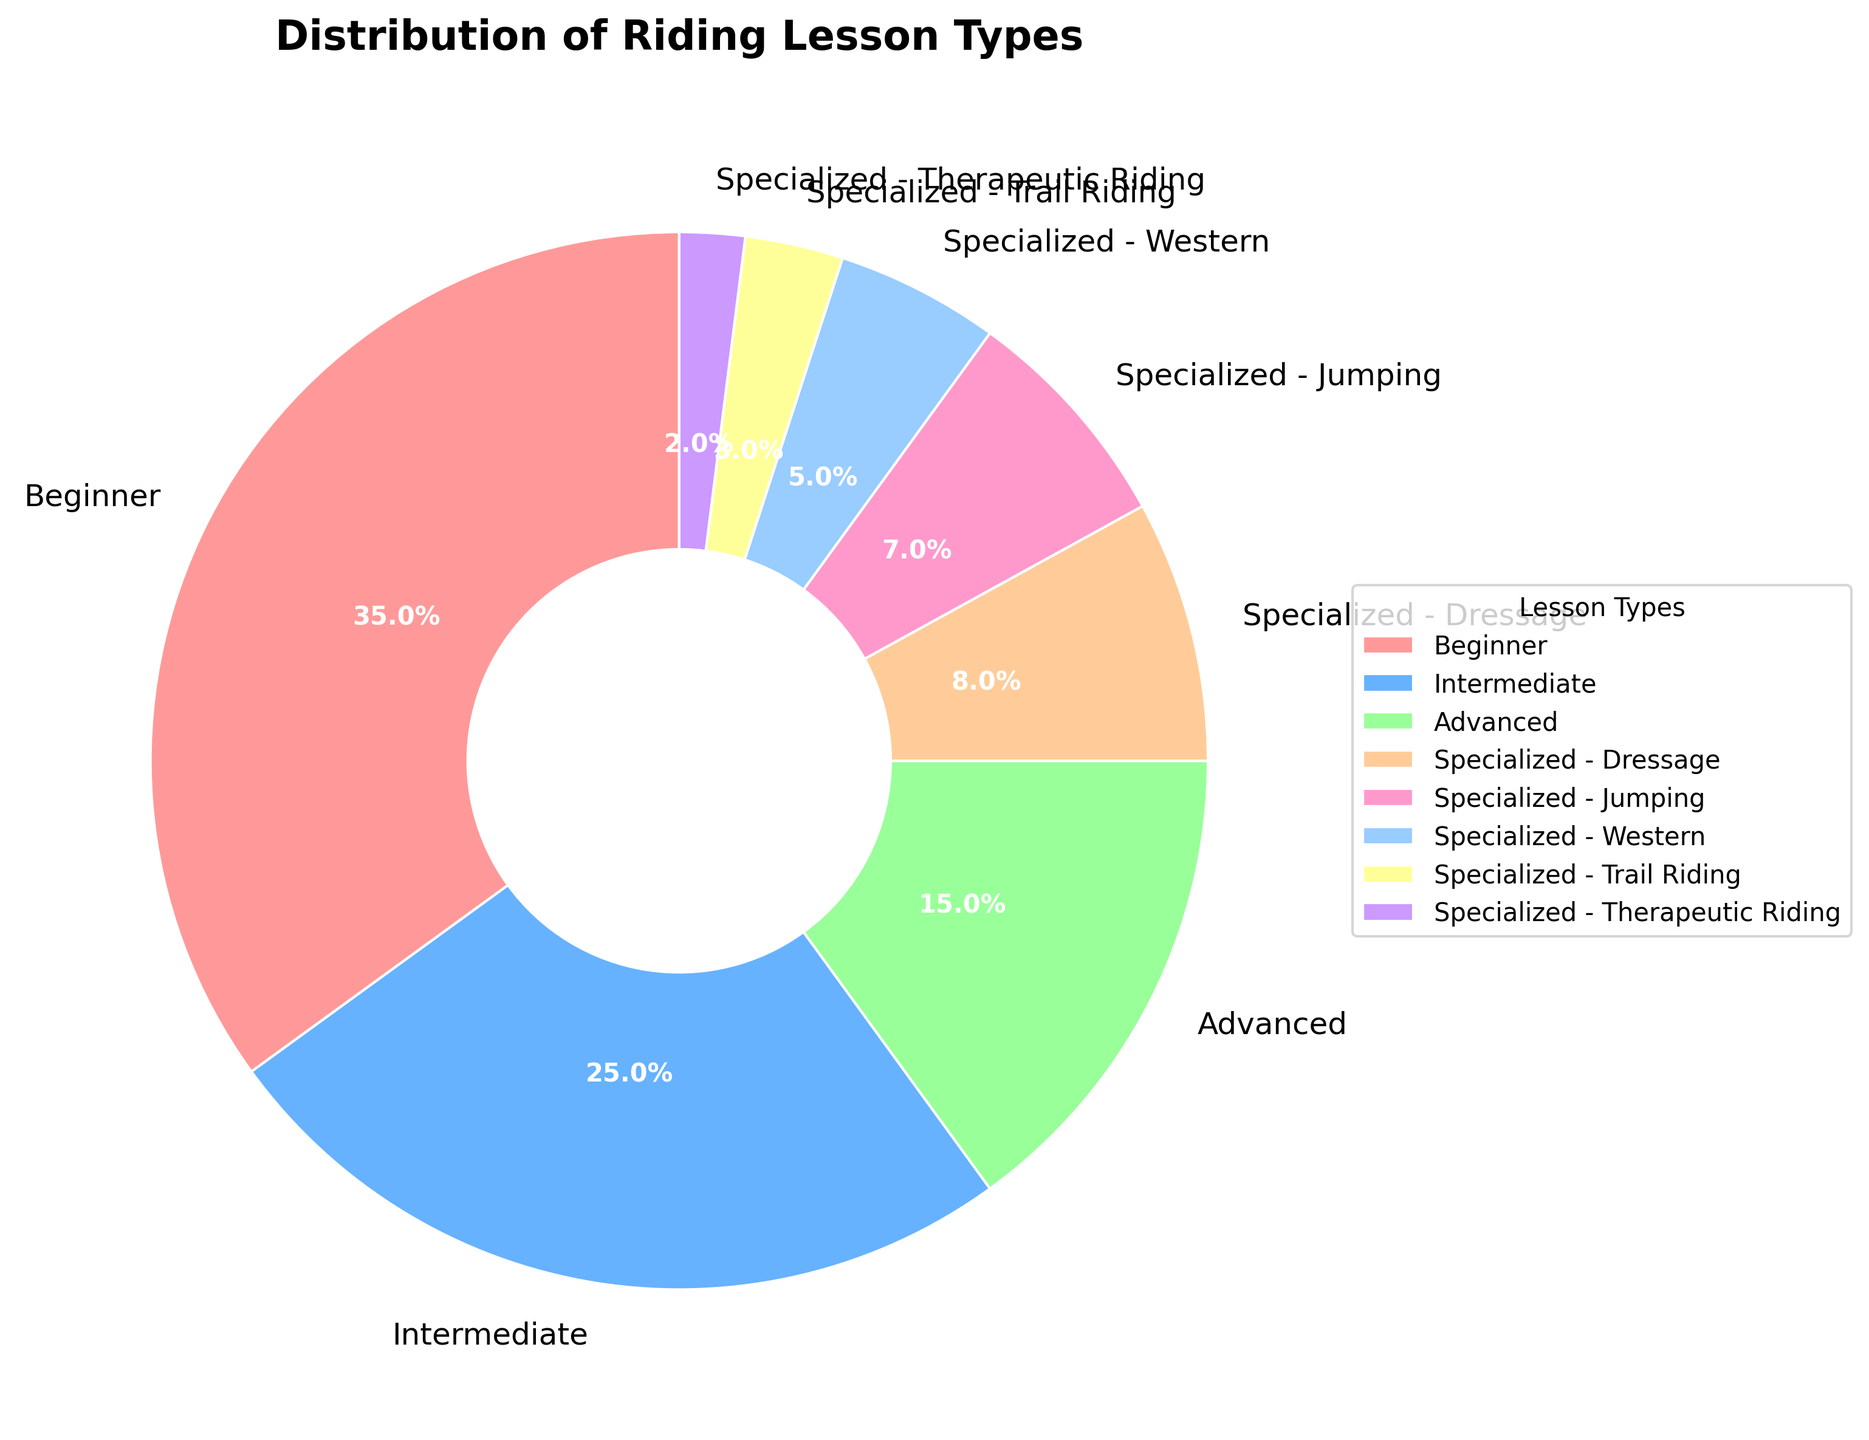What percentage of the riding lessons offered are specialized? To find the total percentage of specialized lessons, sum the percentages of all the specialized lesson types listed. Specialized - Dressage (8%) + Specialized - Jumping (7%) + Specialized - Western (5%) + Specialized - Trail Riding (3%) + Specialized - Therapeutic Riding (2%) = 25%
Answer: 25% Which lesson type has the highest percentage? Examine the figure to identify the lesson type with the largest section (slice) of the pie chart. The "Beginner" lessons have the largest slice at 35%.
Answer: Beginner How much larger is the percentage of Intermediate lessons compared to Advanced lessons? Identify the percentages for Intermediate (25%) and Advanced (15%) lessons, and then subtract the smaller percentage from the larger one. 25% - 15% = 10%
Answer: 10% What is the combined percentage of Beginner and Intermediate lessons? Add the percentages for Beginner (35%) and Intermediate (25%) lessons. 35% + 25% = 60%
Answer: 60% Which specialized lesson type has the smallest percentage, and what is it? Among the specialized lesson types, find the smallest percentage. "Specialized - Therapeutic Riding" has the smallest slice at 2%.
Answer: Specialized - Therapeutic Riding, 2% Is the percentage of Beginner lessons greater than the combined percentage of all Specialized lessons? Compare the percentage of Beginner lessons (35%) with the combined percentage of all specialized lessons (25%). Since 35% is greater than 25%, the percentage of Beginner lessons is greater.
Answer: Yes By how much does the percentage of Specialized - Dressage exceed Specialized - Western? Identify the percentages for Specialized - Dressage (8%) and Specialized - Western (5%) lessons, and then calculate the difference. 8% - 5% = 3%
Answer: 3% What is the total percentage of all riding lesson types offered? Since the pie chart represents all riding lesson types, the total percentage must sum up to 100%.
Answer: 100% Which lesson type has a percentage closest to 10%? Examine the figures in the chart and find the lesson type whose percentage is closest to 10%. "Specialized - Dressage" has a percentage of 8%, which is closest to 10%.
Answer: Specialized - Dressage Are there any lesson types with equal percentages? Check all the percentages in the chart to see if any two lesson types share the same percentage value. No lesson types share the exact same percentage.
Answer: No 